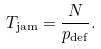<formula> <loc_0><loc_0><loc_500><loc_500>T _ { \text {jam} } = \frac { N } { p _ { \text {def} } } .</formula> 